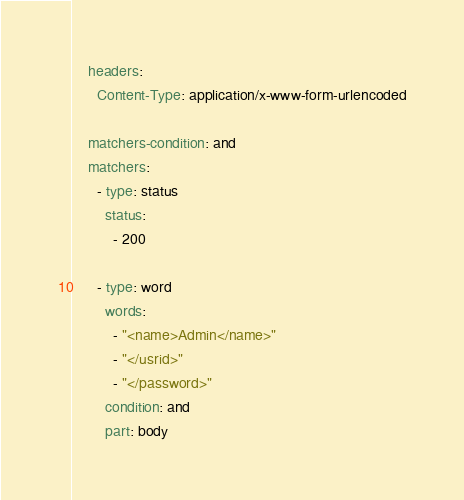<code> <loc_0><loc_0><loc_500><loc_500><_YAML_>    headers:
      Content-Type: application/x-www-form-urlencoded

    matchers-condition: and
    matchers:
      - type: status
        status:
          - 200

      - type: word
        words:
          - "<name>Admin</name>"
          - "</usrid>"
          - "</password>"
        condition: and
        part: body
</code> 